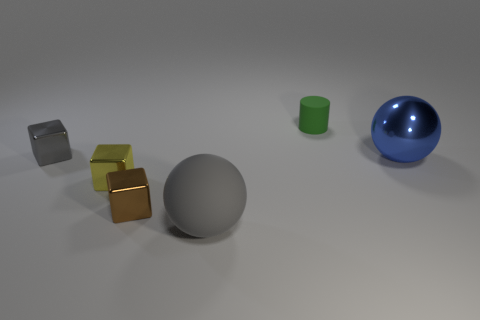What number of big blue things are behind the small thing that is to the right of the big object on the left side of the tiny green rubber cylinder?
Ensure brevity in your answer.  0. There is a gray cube; does it have the same size as the cube to the right of the tiny yellow thing?
Give a very brief answer. Yes. How many gray rubber objects are there?
Keep it short and to the point. 1. There is a matte thing behind the gray block; does it have the same size as the cube that is on the right side of the small yellow metallic block?
Make the answer very short. Yes. What color is the large metal object that is the same shape as the gray rubber thing?
Provide a short and direct response. Blue. Does the blue metallic thing have the same shape as the big rubber thing?
Ensure brevity in your answer.  Yes. There is a gray thing that is the same shape as the brown object; what size is it?
Offer a terse response. Small. What number of balls are made of the same material as the big blue thing?
Your answer should be compact. 0. How many things are either rubber things or tiny shiny objects?
Ensure brevity in your answer.  5. There is a rubber thing that is in front of the small brown block; is there a large object that is behind it?
Your response must be concise. Yes. 